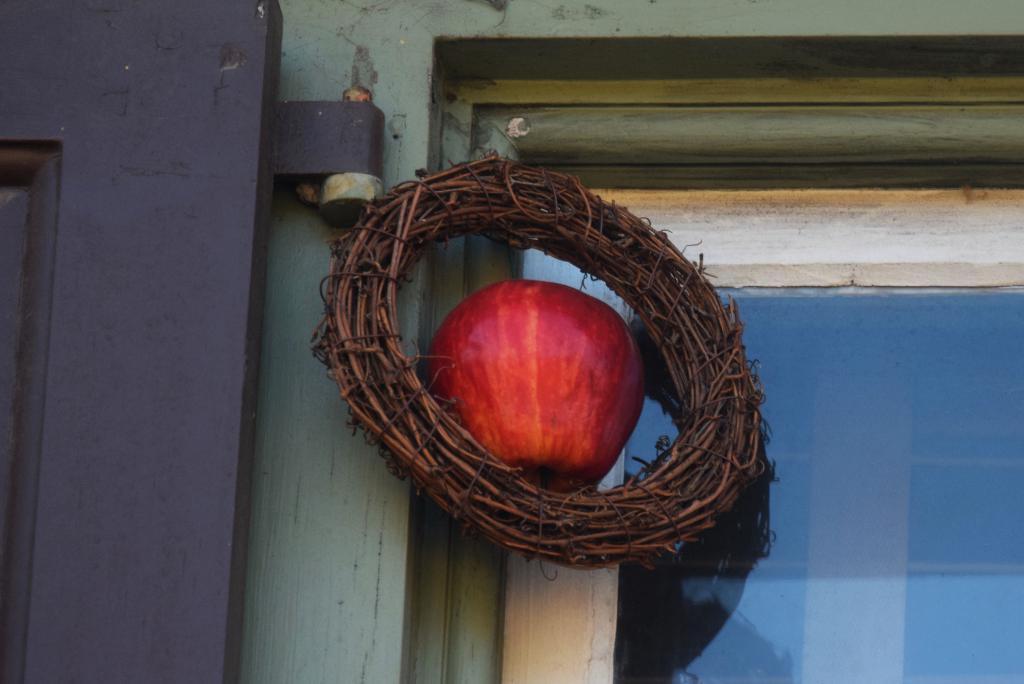Please provide a concise description of this image. In this image there is an apple in the middle. Around the apple there is a wreath. On the right side there is a glass window. On the left side it seems like a door. 